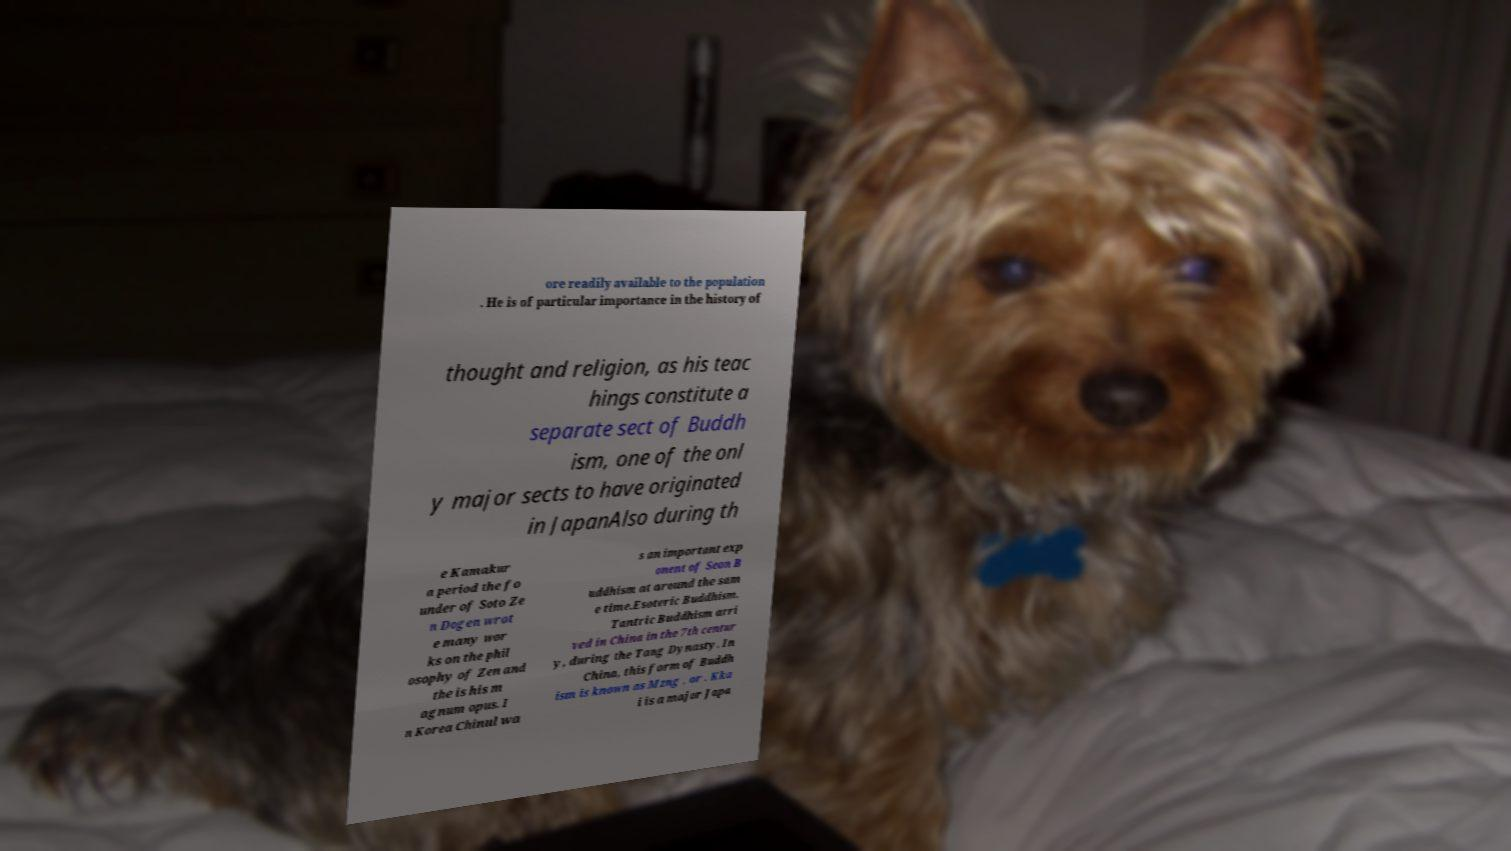Please identify and transcribe the text found in this image. ore readily available to the population . He is of particular importance in the history of thought and religion, as his teac hings constitute a separate sect of Buddh ism, one of the onl y major sects to have originated in JapanAlso during th e Kamakur a period the fo under of Soto Ze n Dogen wrot e many wor ks on the phil osophy of Zen and the is his m agnum opus. I n Korea Chinul wa s an important exp onent of Seon B uddhism at around the sam e time.Esoteric Buddhism. Tantric Buddhism arri ved in China in the 7th centur y, during the Tang Dynasty. In China, this form of Buddh ism is known as Mzng , or . Kka i is a major Japa 